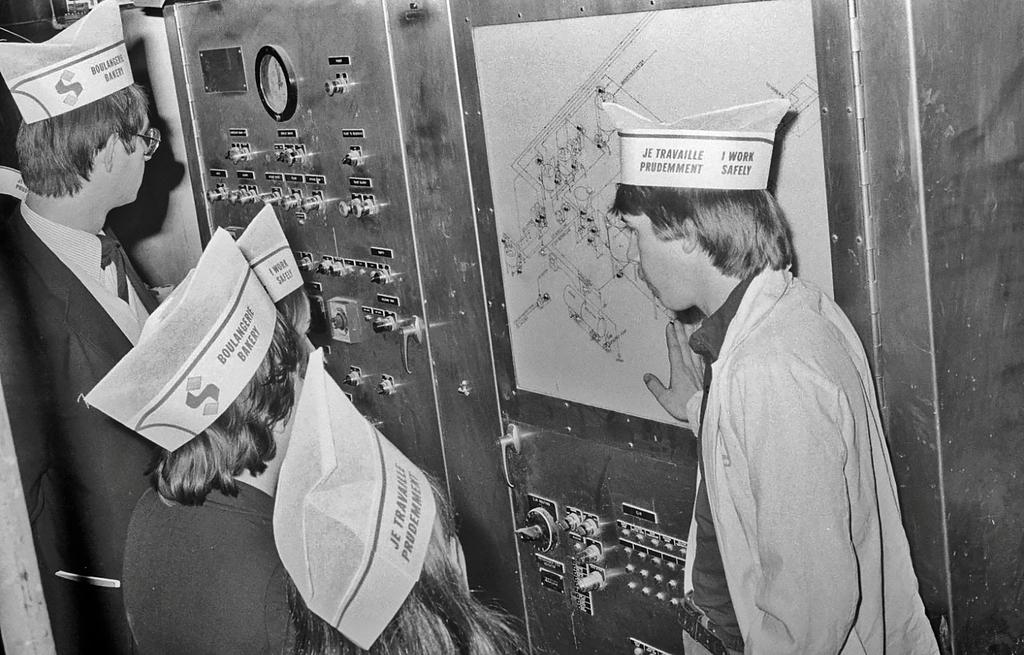What is the color scheme of the image? The image is black and white. What can be seen in the background of the image? There are people standing in front of a machine. What activity is taking place in the image? A person is explaining a map to the people. What type of party is being held in the image? There is no party depicted in the image; it shows people standing in front of a machine and a person explaining a map. How many cups are visible in the image? There are no cups present in the image. 